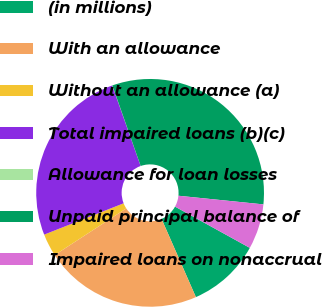Convert chart. <chart><loc_0><loc_0><loc_500><loc_500><pie_chart><fcel>(in millions)<fcel>With an allowance<fcel>Without an allowance (a)<fcel>Total impaired loans (b)(c)<fcel>Allowance for loan losses<fcel>Unpaid principal balance of<fcel>Impaired loans on nonaccrual<nl><fcel>10.39%<fcel>22.39%<fcel>3.22%<fcel>25.58%<fcel>0.02%<fcel>31.99%<fcel>6.41%<nl></chart> 